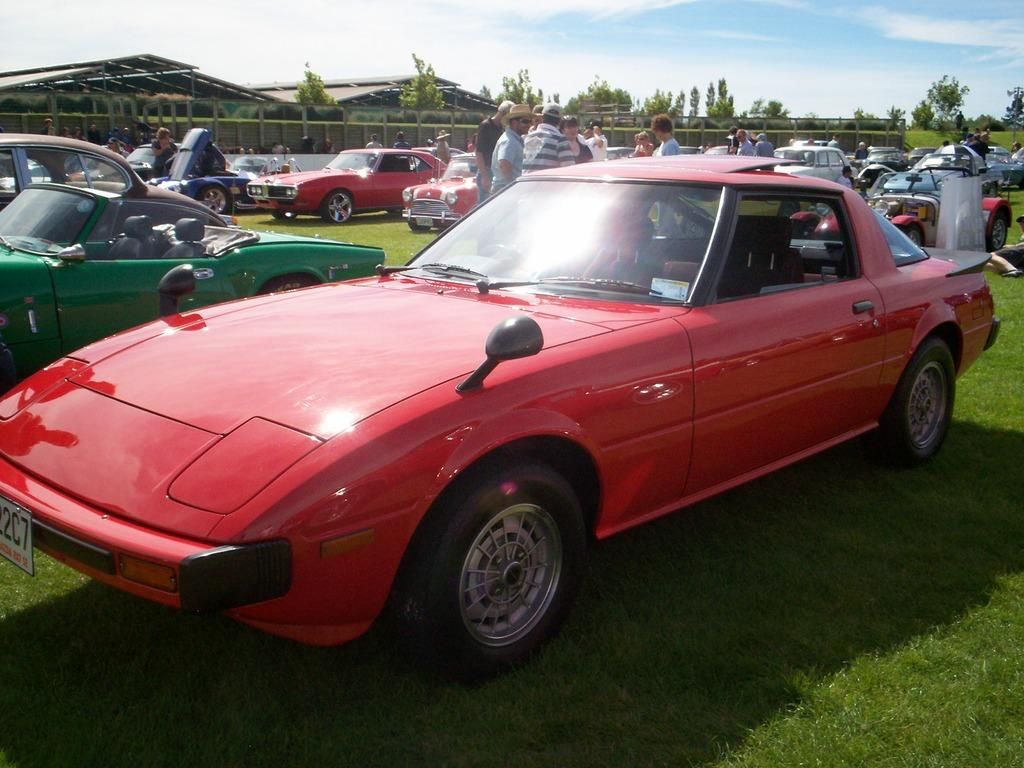What types of objects are present in the image? There are vehicles in the image. What can be seen on the ground in the image? There is grass on the ground in the image. What is visible in the background of the image? There are people, buildings, and trees in the background of the image. What is visible above the background in the image? The sky is visible in the image, and there are clouds in the sky. What type of amusement can be seen in the image? There is no amusement present in the image; it features vehicles, grass, people, buildings, trees, sky, and clouds. How much debt is visible in the image? There is no debt present in the image. 